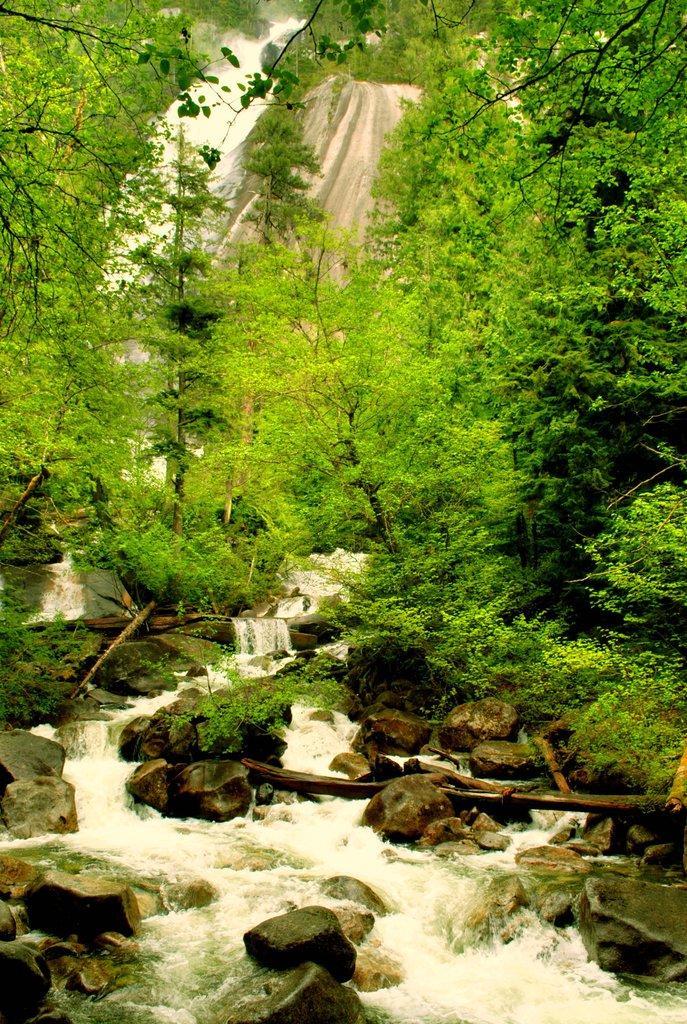Could you give a brief overview of what you see in this image? In the picture we can see a forest view with a hill and water fall from it and to the surface we can see some plants and rocks and water flowing near the rocks. 